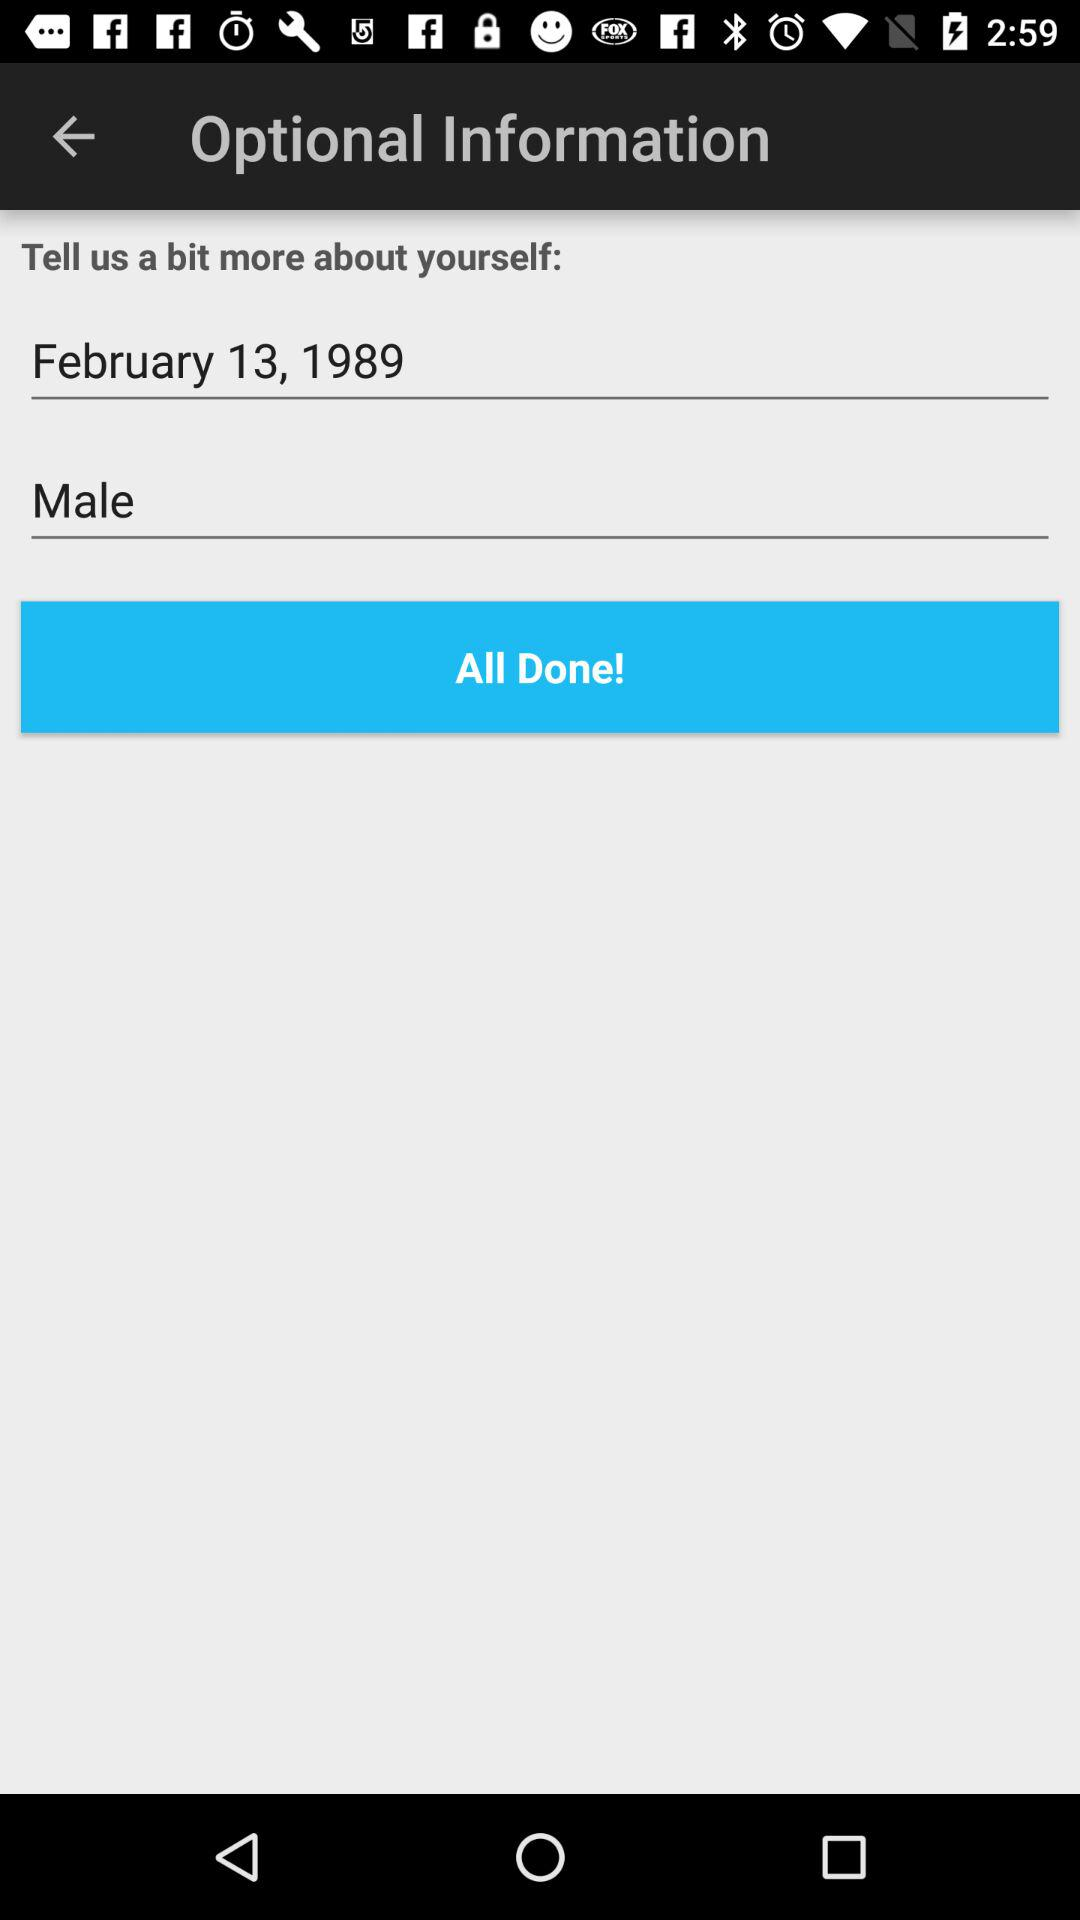What is the given date? The given date is February 13, 1989. 